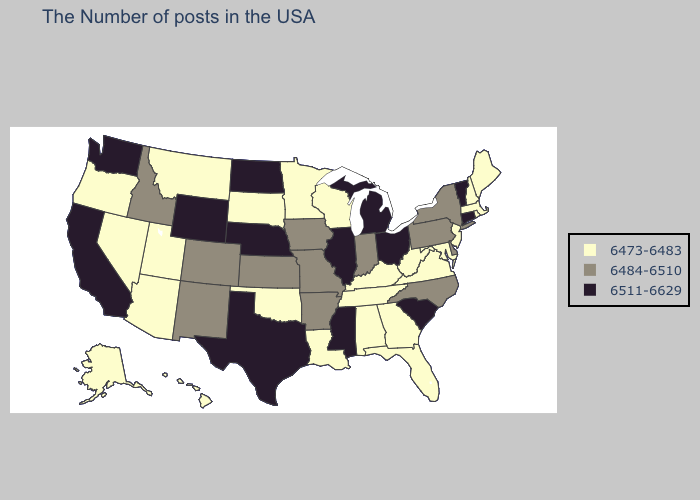Does Vermont have the lowest value in the Northeast?
Short answer required. No. Does the first symbol in the legend represent the smallest category?
Write a very short answer. Yes. Which states have the lowest value in the USA?
Answer briefly. Maine, Massachusetts, Rhode Island, New Hampshire, New Jersey, Maryland, Virginia, West Virginia, Florida, Georgia, Kentucky, Alabama, Tennessee, Wisconsin, Louisiana, Minnesota, Oklahoma, South Dakota, Utah, Montana, Arizona, Nevada, Oregon, Alaska, Hawaii. Does Vermont have the highest value in the Northeast?
Short answer required. Yes. What is the value of New Hampshire?
Keep it brief. 6473-6483. Is the legend a continuous bar?
Keep it brief. No. Is the legend a continuous bar?
Short answer required. No. Which states hav the highest value in the MidWest?
Concise answer only. Ohio, Michigan, Illinois, Nebraska, North Dakota. What is the lowest value in the MidWest?
Concise answer only. 6473-6483. What is the lowest value in the MidWest?
Be succinct. 6473-6483. Name the states that have a value in the range 6473-6483?
Quick response, please. Maine, Massachusetts, Rhode Island, New Hampshire, New Jersey, Maryland, Virginia, West Virginia, Florida, Georgia, Kentucky, Alabama, Tennessee, Wisconsin, Louisiana, Minnesota, Oklahoma, South Dakota, Utah, Montana, Arizona, Nevada, Oregon, Alaska, Hawaii. Name the states that have a value in the range 6473-6483?
Be succinct. Maine, Massachusetts, Rhode Island, New Hampshire, New Jersey, Maryland, Virginia, West Virginia, Florida, Georgia, Kentucky, Alabama, Tennessee, Wisconsin, Louisiana, Minnesota, Oklahoma, South Dakota, Utah, Montana, Arizona, Nevada, Oregon, Alaska, Hawaii. Is the legend a continuous bar?
Quick response, please. No. What is the value of Georgia?
Be succinct. 6473-6483. What is the value of Maine?
Quick response, please. 6473-6483. 